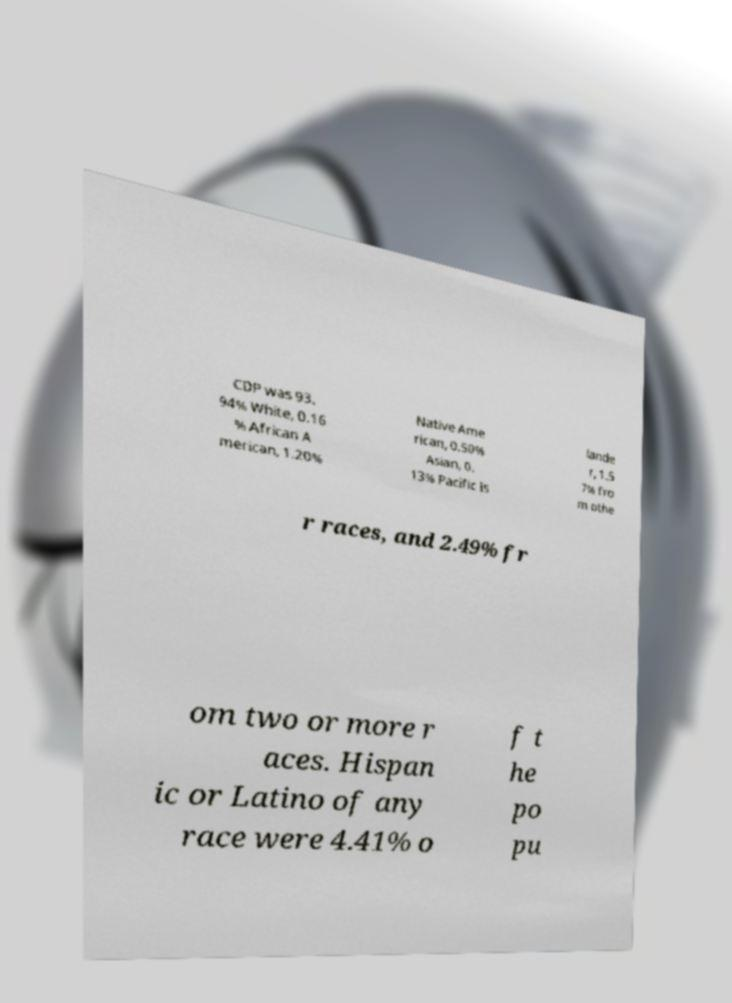For documentation purposes, I need the text within this image transcribed. Could you provide that? CDP was 93. 94% White, 0.16 % African A merican, 1.20% Native Ame rican, 0.50% Asian, 0. 13% Pacific Is lande r, 1.5 7% fro m othe r races, and 2.49% fr om two or more r aces. Hispan ic or Latino of any race were 4.41% o f t he po pu 